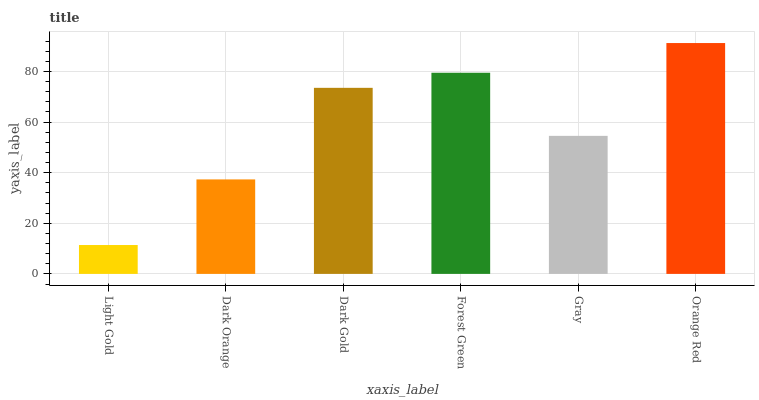Is Light Gold the minimum?
Answer yes or no. Yes. Is Orange Red the maximum?
Answer yes or no. Yes. Is Dark Orange the minimum?
Answer yes or no. No. Is Dark Orange the maximum?
Answer yes or no. No. Is Dark Orange greater than Light Gold?
Answer yes or no. Yes. Is Light Gold less than Dark Orange?
Answer yes or no. Yes. Is Light Gold greater than Dark Orange?
Answer yes or no. No. Is Dark Orange less than Light Gold?
Answer yes or no. No. Is Dark Gold the high median?
Answer yes or no. Yes. Is Gray the low median?
Answer yes or no. Yes. Is Gray the high median?
Answer yes or no. No. Is Dark Orange the low median?
Answer yes or no. No. 